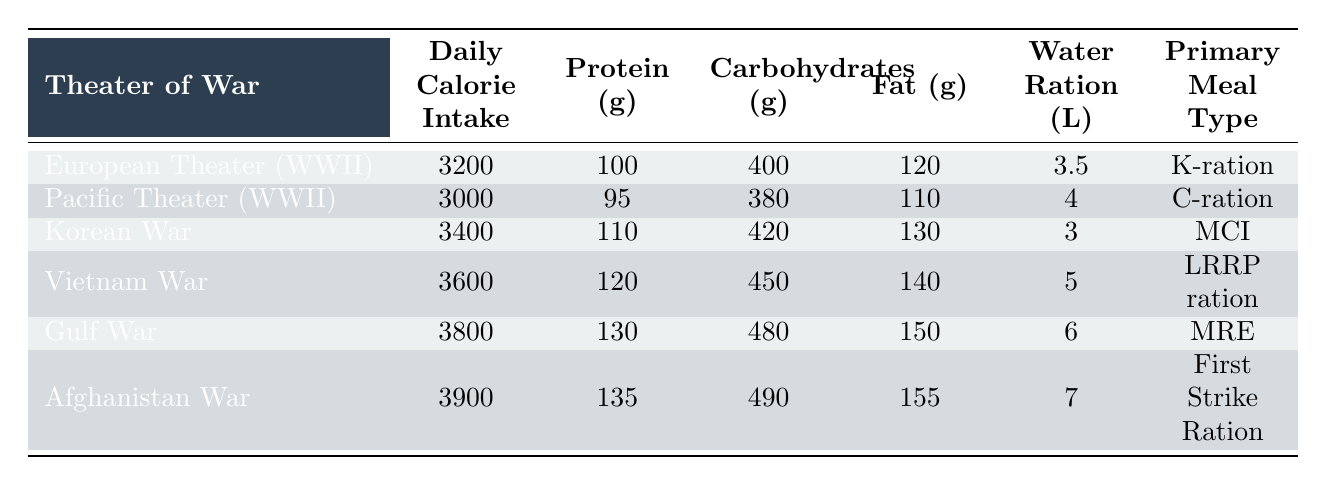What is the daily calorie intake for ground crew members in the Gulf War? The table lists the daily calorie intake for the Gulf War as 3800 calories.
Answer: 3800 Which theater of war had the highest protein allocation? The table shows that the Afghanistan War had the highest protein allocation with 135 grams.
Answer: 135 grams How many liters of water are allocated daily for the Vietnam War? According to the table, the daily water ration for the Vietnam War is 5 liters.
Answer: 5 liters What is the total amount of carbohydrates allocated to ground crew members in the Korean War and Gulf War combined? The Korean War has 420 grams and the Gulf War has 480 grams of carbohydrates. Adding these gives 420 + 480 = 900 grams.
Answer: 900 grams Which meal type has the lowest daily calorie intake? Comparing the meal types, the Pacific Theater (C-ration) has the lowest daily calorie intake of 3000 calories.
Answer: C-ration Is it true that ground crew members in the European Theater receive more calories than those in the Pacific Theater? The table shows that the European Theater has 3200 calories while the Pacific Theater has 3000 calories, confirming that the statement is true.
Answer: Yes What is the average daily calorie intake across all theaters of war listed in the table? To find the average, sum up the daily calorie intakes (3200 + 3000 + 3400 + 3600 + 3800 + 3900 = 22900) and divide by 6, yielding an average of 3816.67 calories.
Answer: 3816.67 Which theater of war has the highest fat allocation and what is that amount? According to the table, the Afghanistan War has the highest fat allocation at 155 grams.
Answer: 155 grams Are the daily calorie intakes for the Korean War and Vietnam War above or below 3500 calories? The Korean War has 3400 calories, which is below 3500, while the Vietnam War has 3600 calories, which is above 3500. Therefore, the statistics are mixed for this question.
Answer: Mixed What is the difference in daily protein allocation between the Gulf War and the Vietnam War? The Gulf War allocates 130 grams of protein while the Vietnam War allocates 120 grams. The difference is 130 - 120 = 10 grams.
Answer: 10 grams 